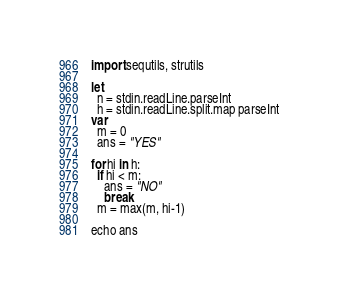Convert code to text. <code><loc_0><loc_0><loc_500><loc_500><_Nim_>import sequtils, strutils

let
  n = stdin.readLine.parseInt
  h = stdin.readLine.split.map parseInt
var
  m = 0
  ans = "YES"

for hi in h:
  if hi < m:
    ans = "NO"
    break
  m = max(m, hi-1)

echo ans</code> 